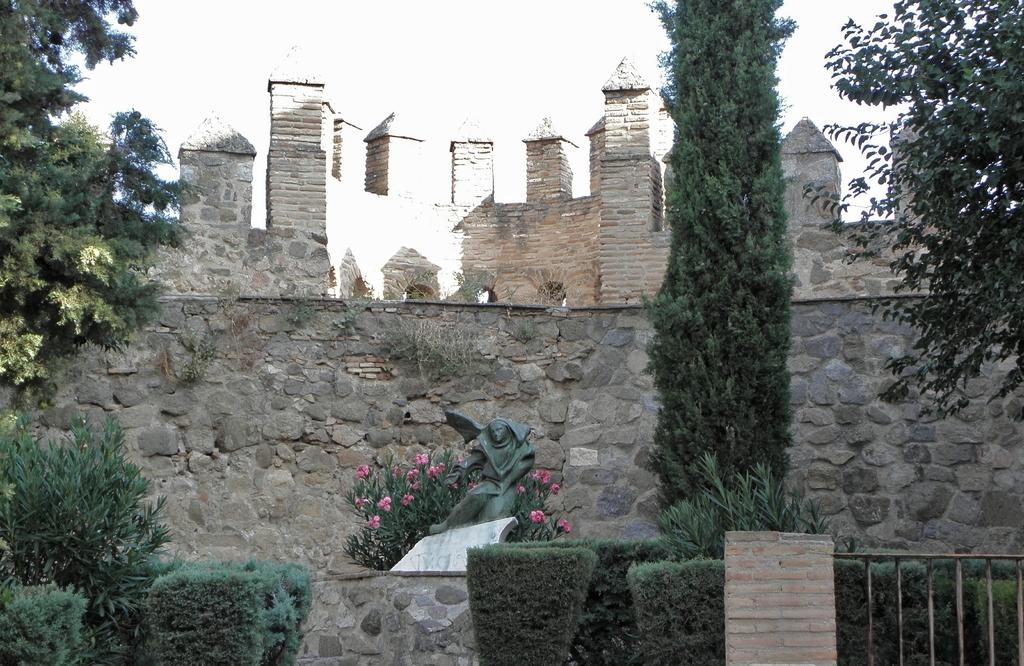What is the main subject in the image? There is a statue in the image. What can be seen on the plants in the image? There are flowers on the plants in the image. What type of vegetation is present in the image? There are trees and bushes in the image. What can be seen in the background of the image? There is a building visible in the background of the image. What type of skirt is the statue wearing in the image? The statue is not wearing a skirt, as it is a statue and not a person. 